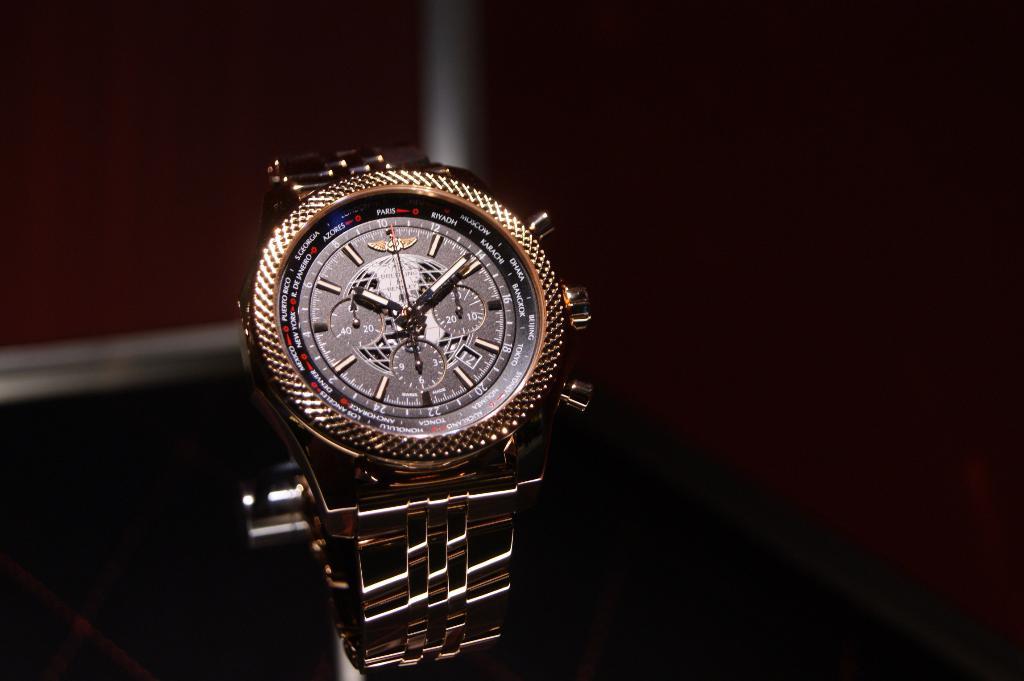What time is on the watch?
Ensure brevity in your answer.  10:10. 